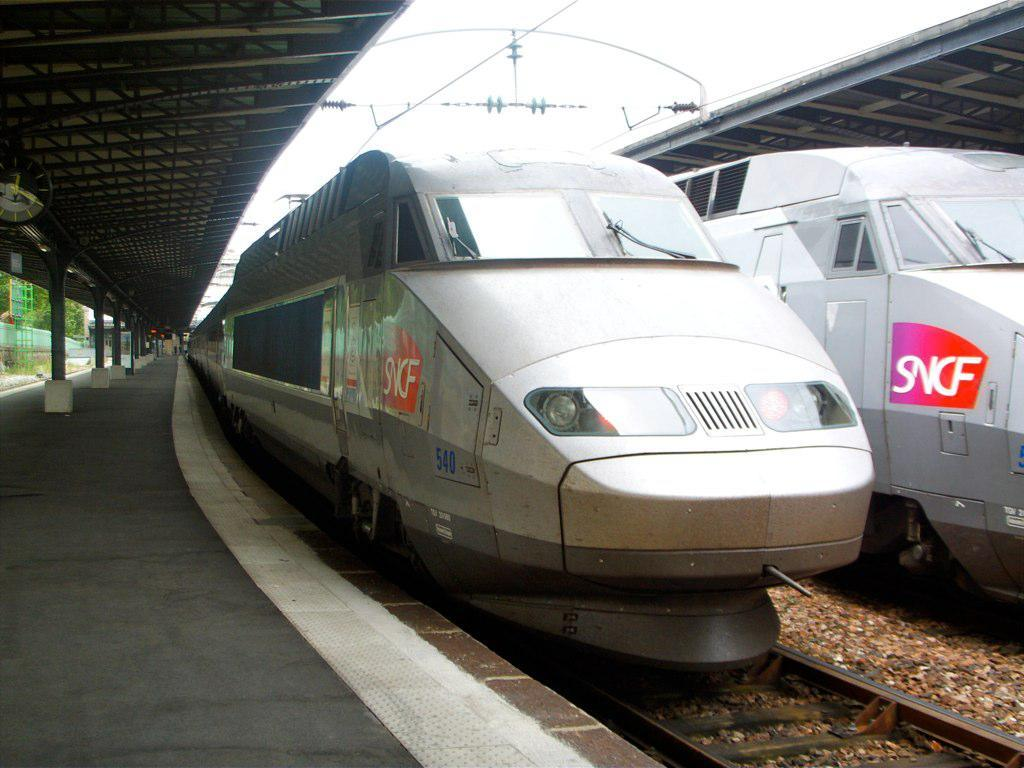<image>
Relay a brief, clear account of the picture shown. Two modern trains both have an SNCF logo on the side near the front. 